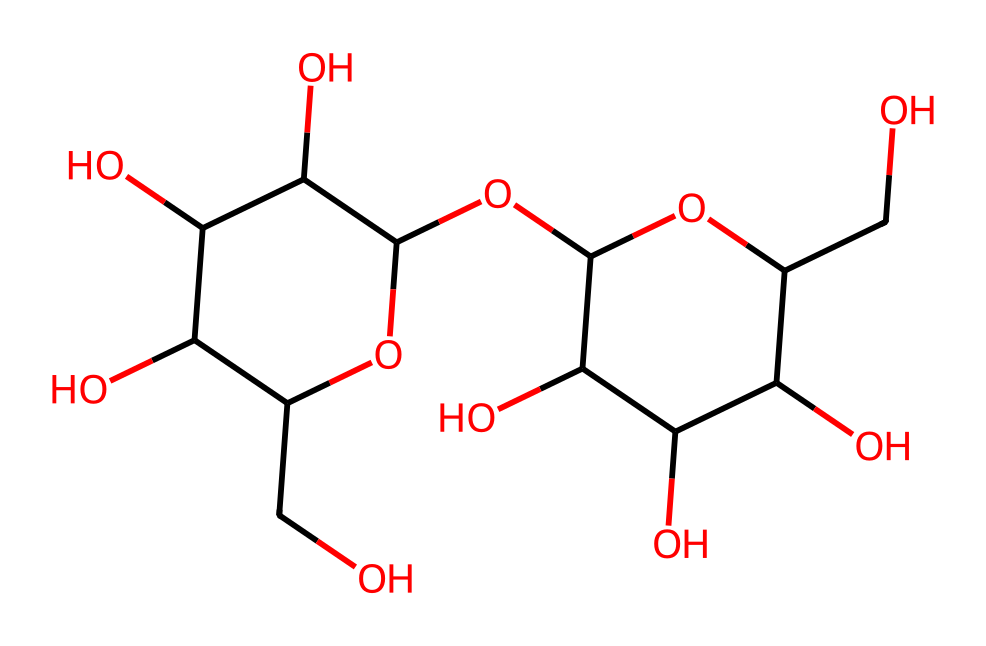how many carbon atoms are present in this structure? By counting the "C" symbols in the SMILES representation, we can determine the number of carbon atoms. Each "C" represents a carbon atom; thus we count each one to find the total.
Answer: ten how many hydroxyl (–OH) groups are in this molecule? In the SMILES representation, we look for occurrences of the “O” that are directly followed by “(” which indicates the presence of hydroxyl groups. After identifying them, we count their total quantity.
Answer: six what type of carbohydrate does this structure represent? The structure is indicative of starch, as it is composed of multiple glucose units linked together. The presence of multiple –OH groups supports this classification.
Answer: starch how many rings are involved in the molecular structure? By analyzing the SMILES notation, we observe the numbers that indicate ring formation (i.e., C1 and C2). Each set of recurring numbers represents a unique ring structure; we tally these to determine the total.
Answer: two how many oxygen atoms are present in this structure? We count the number of “O” symbols or the presence of hydroxyl groups in the structure. Since each atom is represented distinctly, counting “O” will give the total number of oxygen atoms.
Answer: six how does this carbohydrate contribute to the sustainability of building materials? Starch is biodegradable and can enhance material properties such as strength and insulation. Its renewable nature and ability to reduce waste contribute to sustainability in construction.
Answer: biodegradable 